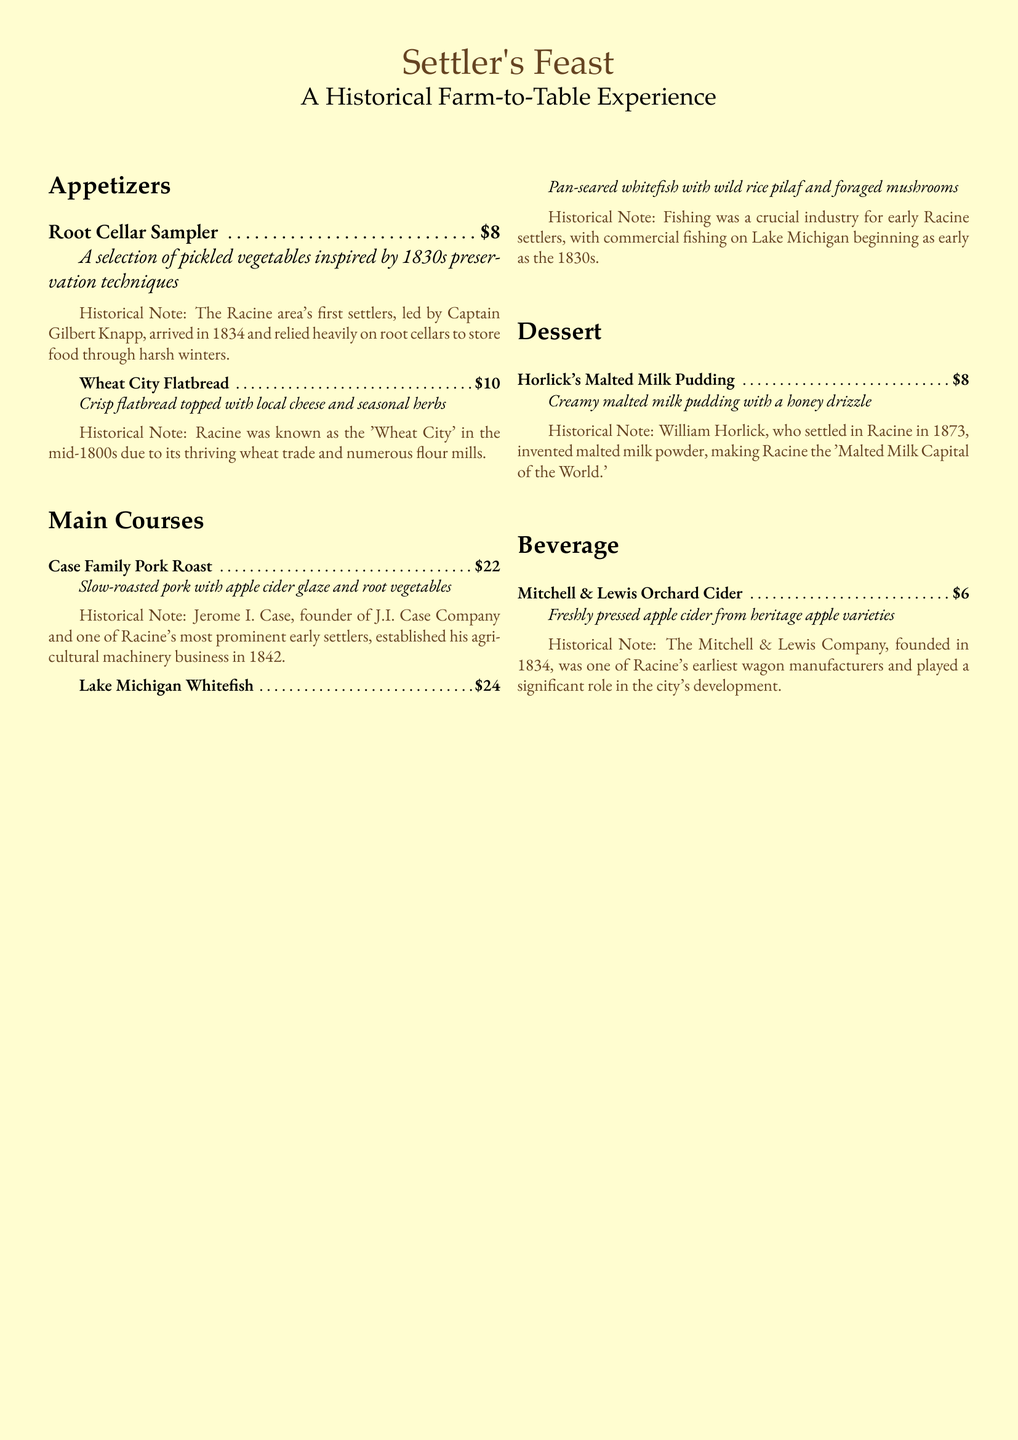What is the price of the Root Cellar Sampler? The price is listed next to the menu item in the document.
Answer: $8 Who invented malted milk powder? This information is found in the historical note for the dessert.
Answer: William Horlick What historical period does the Wheat City Flatbread pay tribute to? The description of the flatbread indicates its inspiration from Racine's history.
Answer: Mid-1800s How much does the Lake Michigan Whitefish cost? The cost is specified under the main course section of the menu.
Answer: $24 What type of cider is offered in the beverage section? This detail is mentioned directly in the beverage menu item.
Answer: Orchard Cider What was Racine known as in the mid-1800s? The historical note details Racine's nickname during that time.
Answer: Wheat City What technique inspired the Root Cellar Sampler? The description of the dish provides this information.
Answer: Preservation techniques Which early settler established an agricultural machinery business in 1842? The historical fact notes the founder's name along with the year of establishment.
Answer: Jerome I. Case 